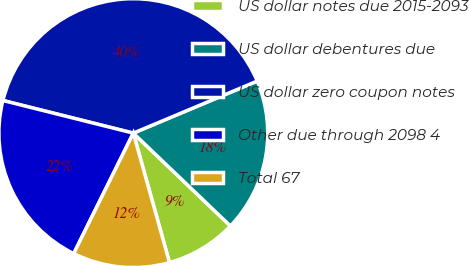Convert chart to OTSL. <chart><loc_0><loc_0><loc_500><loc_500><pie_chart><fcel>US dollar notes due 2015-2093<fcel>US dollar debentures due<fcel>US dollar zero coupon notes<fcel>Other due through 2098 4<fcel>Total 67<nl><fcel>8.52%<fcel>18.47%<fcel>39.77%<fcel>21.59%<fcel>11.65%<nl></chart> 